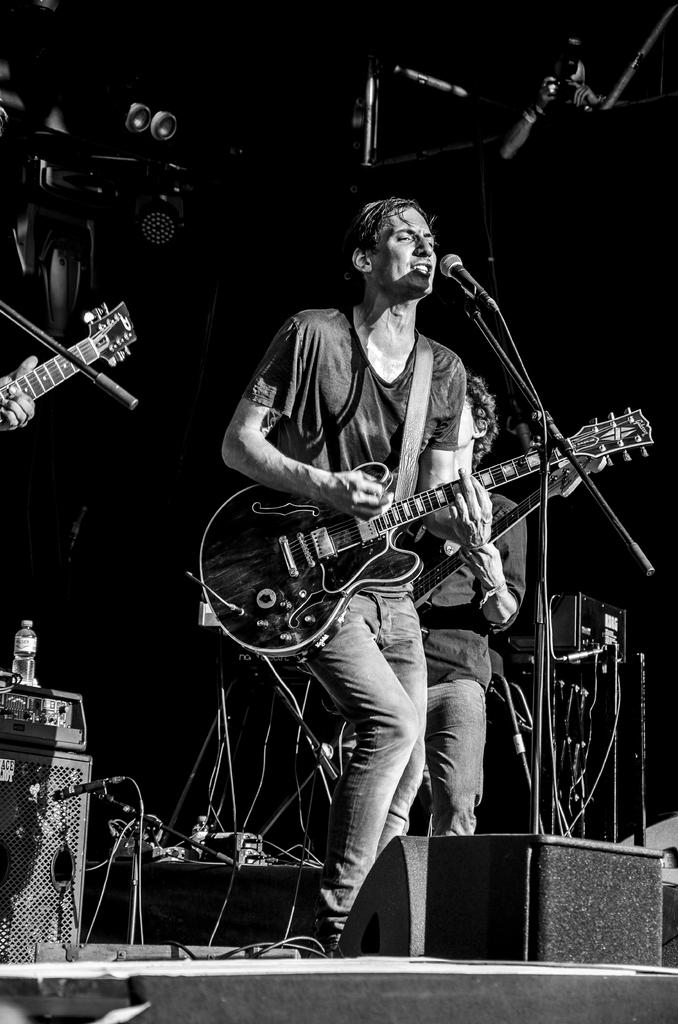What is the man in the image doing? The man is singing and playing the guitar in the image. What type of clothing is the man wearing on his upper body? The man is wearing a t-shirt in the image. What type of clothing is the man wearing on his lower body? The man is wearing trousers in the image. What is the color scheme of the image? The image is in black and white color. What type of seat is the man using to play the guitar in the image? There is no seat visible in the image; the man is standing while playing the guitar. 